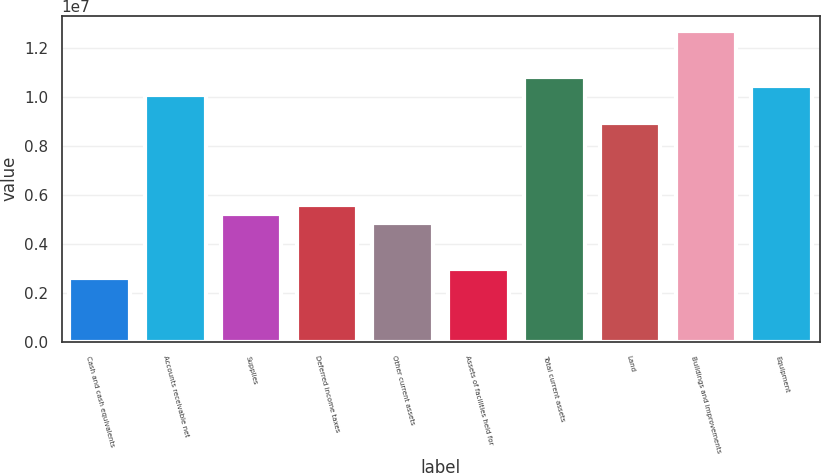Convert chart to OTSL. <chart><loc_0><loc_0><loc_500><loc_500><bar_chart><fcel>Cash and cash equivalents<fcel>Accounts receivable net<fcel>Supplies<fcel>Deferred income taxes<fcel>Other current assets<fcel>Assets of facilities held for<fcel>Total current assets<fcel>Land<fcel>Buildings and improvements<fcel>Equipment<nl><fcel>2.6092e+06<fcel>1.00641e+07<fcel>5.2184e+06<fcel>5.59115e+06<fcel>4.84566e+06<fcel>2.98195e+06<fcel>1.08095e+07<fcel>8.94583e+06<fcel>1.26733e+07<fcel>1.04368e+07<nl></chart> 